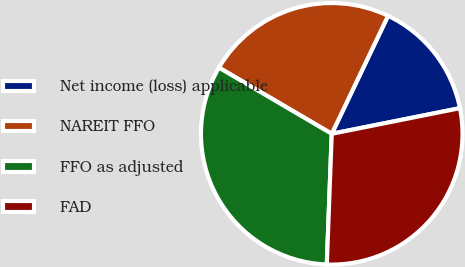Convert chart to OTSL. <chart><loc_0><loc_0><loc_500><loc_500><pie_chart><fcel>Net income (loss) applicable<fcel>NAREIT FFO<fcel>FFO as adjusted<fcel>FAD<nl><fcel>14.77%<fcel>23.64%<fcel>32.84%<fcel>28.74%<nl></chart> 